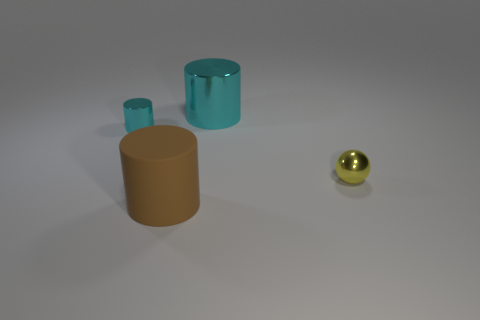Is there anything else that is the same shape as the yellow metallic object?
Provide a succinct answer. No. The tiny shiny object that is behind the yellow ball has what shape?
Ensure brevity in your answer.  Cylinder. What is the material of the thing that is the same color as the small cylinder?
Offer a terse response. Metal. What color is the tiny thing that is in front of the small shiny object to the left of the big cyan thing?
Make the answer very short. Yellow. There is another large brown object that is the same shape as the big shiny object; what is it made of?
Provide a short and direct response. Rubber. What number of cyan things are the same size as the yellow metallic ball?
Give a very brief answer. 1. What color is the other small object that is made of the same material as the tiny yellow thing?
Provide a short and direct response. Cyan. Are there fewer blue metallic cubes than metallic cylinders?
Give a very brief answer. Yes. How many yellow objects are either tiny cylinders or metal things?
Offer a terse response. 1. What number of metal objects are both behind the yellow thing and to the right of the brown rubber cylinder?
Your response must be concise. 1. 